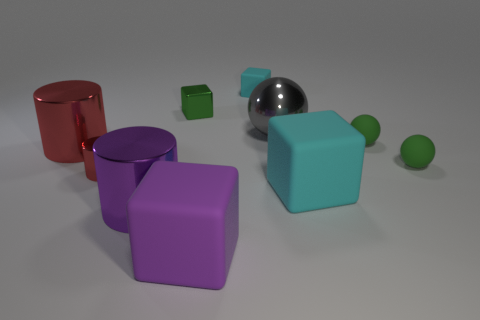How many things are either big green rubber cylinders or big objects?
Keep it short and to the point. 5. There is a cyan matte cube behind the large gray ball; what is its size?
Ensure brevity in your answer.  Small. What is the color of the large shiny object that is behind the tiny cylinder and to the right of the large red thing?
Offer a very short reply. Gray. Is the material of the big purple object to the left of the small shiny cube the same as the big cyan object?
Provide a succinct answer. No. Does the metallic cube have the same color as the small ball that is in front of the large red cylinder?
Provide a succinct answer. Yes. There is a small cyan cube; are there any large things to the right of it?
Offer a terse response. Yes. There is a cyan thing right of the big metallic ball; is its size the same as the metal sphere that is behind the big red shiny cylinder?
Give a very brief answer. Yes. Is there a cylinder of the same size as the gray shiny ball?
Offer a terse response. Yes. There is a purple thing behind the big purple matte thing; is it the same shape as the small red metal object?
Your response must be concise. Yes. What is the material of the green thing to the left of the small cyan thing?
Offer a very short reply. Metal. 